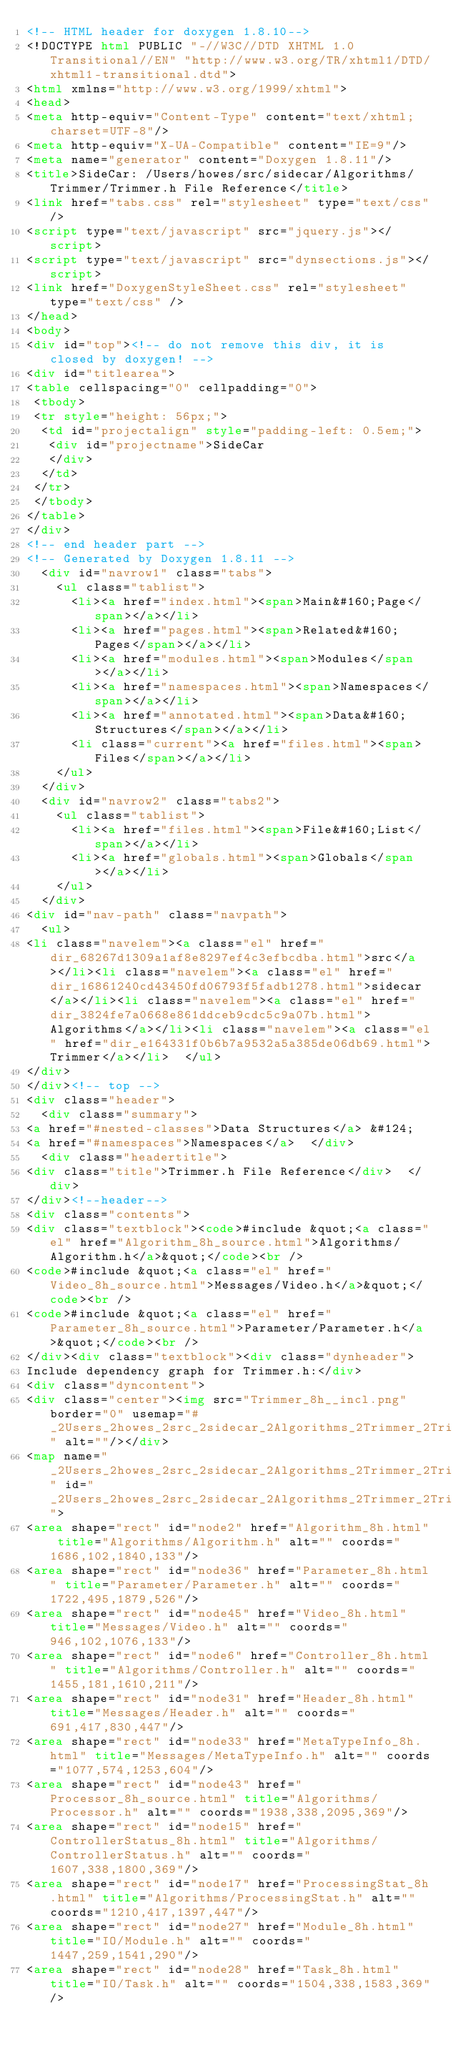Convert code to text. <code><loc_0><loc_0><loc_500><loc_500><_HTML_><!-- HTML header for doxygen 1.8.10-->
<!DOCTYPE html PUBLIC "-//W3C//DTD XHTML 1.0 Transitional//EN" "http://www.w3.org/TR/xhtml1/DTD/xhtml1-transitional.dtd">
<html xmlns="http://www.w3.org/1999/xhtml">
<head>
<meta http-equiv="Content-Type" content="text/xhtml;charset=UTF-8"/>
<meta http-equiv="X-UA-Compatible" content="IE=9"/>
<meta name="generator" content="Doxygen 1.8.11"/>
<title>SideCar: /Users/howes/src/sidecar/Algorithms/Trimmer/Trimmer.h File Reference</title>
<link href="tabs.css" rel="stylesheet" type="text/css"/>
<script type="text/javascript" src="jquery.js"></script>
<script type="text/javascript" src="dynsections.js"></script>
<link href="DoxygenStyleSheet.css" rel="stylesheet" type="text/css" />
</head>
<body>
<div id="top"><!-- do not remove this div, it is closed by doxygen! -->
<div id="titlearea">
<table cellspacing="0" cellpadding="0">
 <tbody>
 <tr style="height: 56px;">
  <td id="projectalign" style="padding-left: 0.5em;">
   <div id="projectname">SideCar
   </div>
  </td>
 </tr>
 </tbody>
</table>
</div>
<!-- end header part -->
<!-- Generated by Doxygen 1.8.11 -->
  <div id="navrow1" class="tabs">
    <ul class="tablist">
      <li><a href="index.html"><span>Main&#160;Page</span></a></li>
      <li><a href="pages.html"><span>Related&#160;Pages</span></a></li>
      <li><a href="modules.html"><span>Modules</span></a></li>
      <li><a href="namespaces.html"><span>Namespaces</span></a></li>
      <li><a href="annotated.html"><span>Data&#160;Structures</span></a></li>
      <li class="current"><a href="files.html"><span>Files</span></a></li>
    </ul>
  </div>
  <div id="navrow2" class="tabs2">
    <ul class="tablist">
      <li><a href="files.html"><span>File&#160;List</span></a></li>
      <li><a href="globals.html"><span>Globals</span></a></li>
    </ul>
  </div>
<div id="nav-path" class="navpath">
  <ul>
<li class="navelem"><a class="el" href="dir_68267d1309a1af8e8297ef4c3efbcdba.html">src</a></li><li class="navelem"><a class="el" href="dir_16861240cd43450fd06793f5fadb1278.html">sidecar</a></li><li class="navelem"><a class="el" href="dir_3824fe7a0668e861ddceb9cdc5c9a07b.html">Algorithms</a></li><li class="navelem"><a class="el" href="dir_e164331f0b6b7a9532a5a385de06db69.html">Trimmer</a></li>  </ul>
</div>
</div><!-- top -->
<div class="header">
  <div class="summary">
<a href="#nested-classes">Data Structures</a> &#124;
<a href="#namespaces">Namespaces</a>  </div>
  <div class="headertitle">
<div class="title">Trimmer.h File Reference</div>  </div>
</div><!--header-->
<div class="contents">
<div class="textblock"><code>#include &quot;<a class="el" href="Algorithm_8h_source.html">Algorithms/Algorithm.h</a>&quot;</code><br />
<code>#include &quot;<a class="el" href="Video_8h_source.html">Messages/Video.h</a>&quot;</code><br />
<code>#include &quot;<a class="el" href="Parameter_8h_source.html">Parameter/Parameter.h</a>&quot;</code><br />
</div><div class="textblock"><div class="dynheader">
Include dependency graph for Trimmer.h:</div>
<div class="dyncontent">
<div class="center"><img src="Trimmer_8h__incl.png" border="0" usemap="#_2Users_2howes_2src_2sidecar_2Algorithms_2Trimmer_2Trimmer_8h" alt=""/></div>
<map name="_2Users_2howes_2src_2sidecar_2Algorithms_2Trimmer_2Trimmer_8h" id="_2Users_2howes_2src_2sidecar_2Algorithms_2Trimmer_2Trimmer_8h">
<area shape="rect" id="node2" href="Algorithm_8h.html" title="Algorithms/Algorithm.h" alt="" coords="1686,102,1840,133"/>
<area shape="rect" id="node36" href="Parameter_8h.html" title="Parameter/Parameter.h" alt="" coords="1722,495,1879,526"/>
<area shape="rect" id="node45" href="Video_8h.html" title="Messages/Video.h" alt="" coords="946,102,1076,133"/>
<area shape="rect" id="node6" href="Controller_8h.html" title="Algorithms/Controller.h" alt="" coords="1455,181,1610,211"/>
<area shape="rect" id="node31" href="Header_8h.html" title="Messages/Header.h" alt="" coords="691,417,830,447"/>
<area shape="rect" id="node33" href="MetaTypeInfo_8h.html" title="Messages/MetaTypeInfo.h" alt="" coords="1077,574,1253,604"/>
<area shape="rect" id="node43" href="Processor_8h_source.html" title="Algorithms/Processor.h" alt="" coords="1938,338,2095,369"/>
<area shape="rect" id="node15" href="ControllerStatus_8h.html" title="Algorithms/ControllerStatus.h" alt="" coords="1607,338,1800,369"/>
<area shape="rect" id="node17" href="ProcessingStat_8h.html" title="Algorithms/ProcessingStat.h" alt="" coords="1210,417,1397,447"/>
<area shape="rect" id="node27" href="Module_8h.html" title="IO/Module.h" alt="" coords="1447,259,1541,290"/>
<area shape="rect" id="node28" href="Task_8h.html" title="IO/Task.h" alt="" coords="1504,338,1583,369"/></code> 